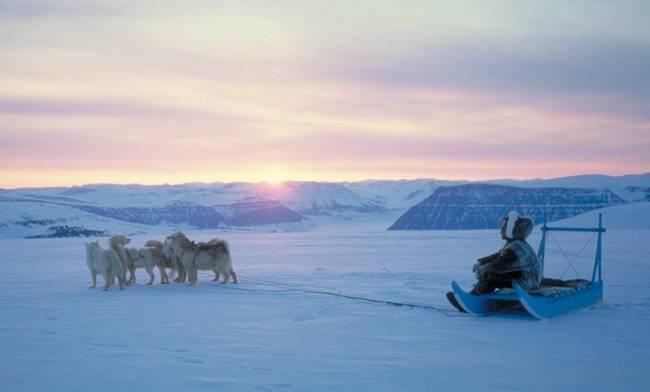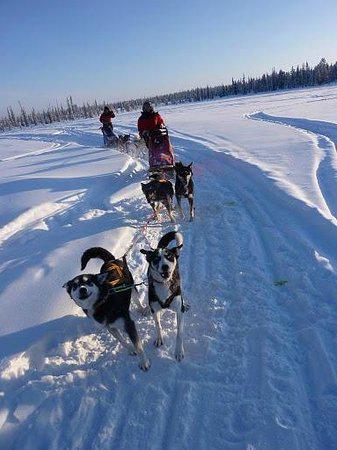The first image is the image on the left, the second image is the image on the right. Given the left and right images, does the statement "An image shows a team of sled dogs headed toward the camera." hold true? Answer yes or no. Yes. The first image is the image on the left, the second image is the image on the right. Given the left and right images, does the statement "The sled dogs are resting in one of the images." hold true? Answer yes or no. Yes. 